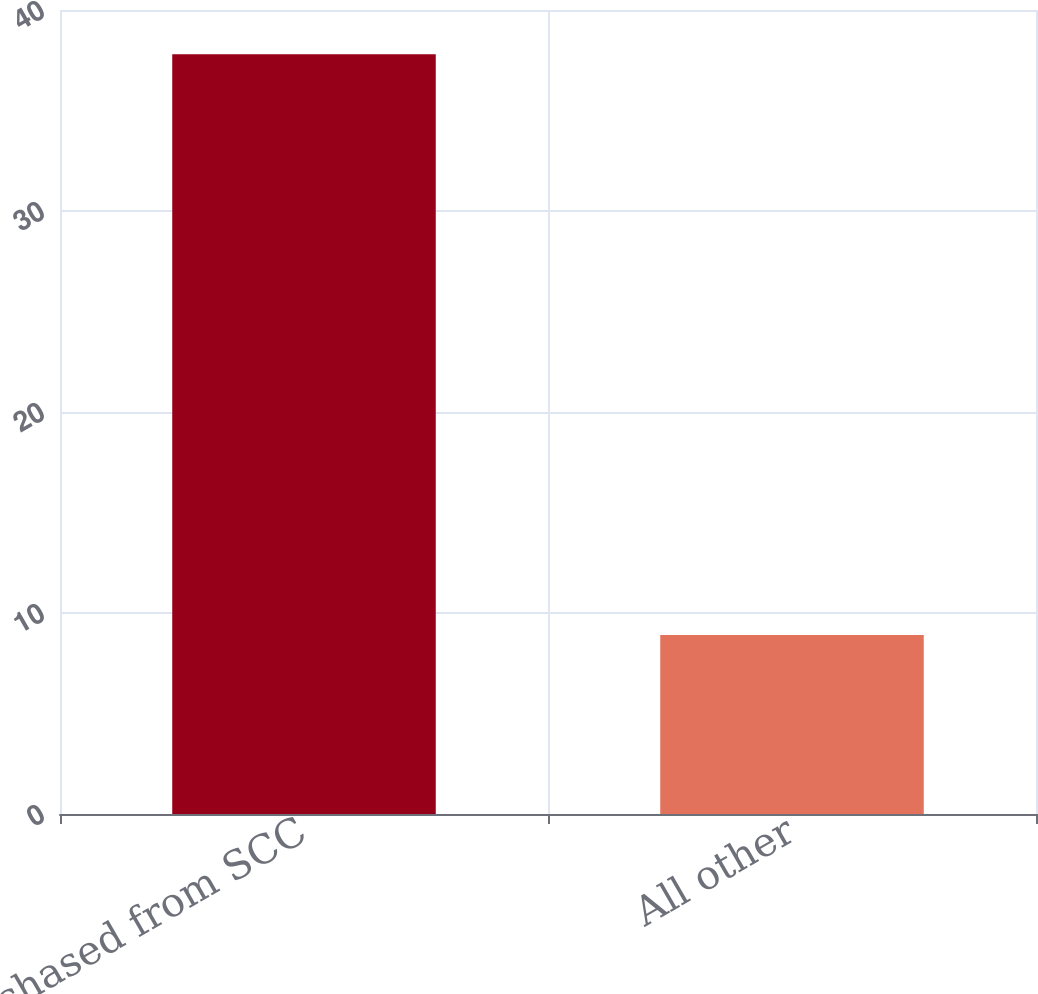Convert chart to OTSL. <chart><loc_0><loc_0><loc_500><loc_500><bar_chart><fcel>Purchased from SCC<fcel>All other<nl><fcel>37.8<fcel>8.9<nl></chart> 